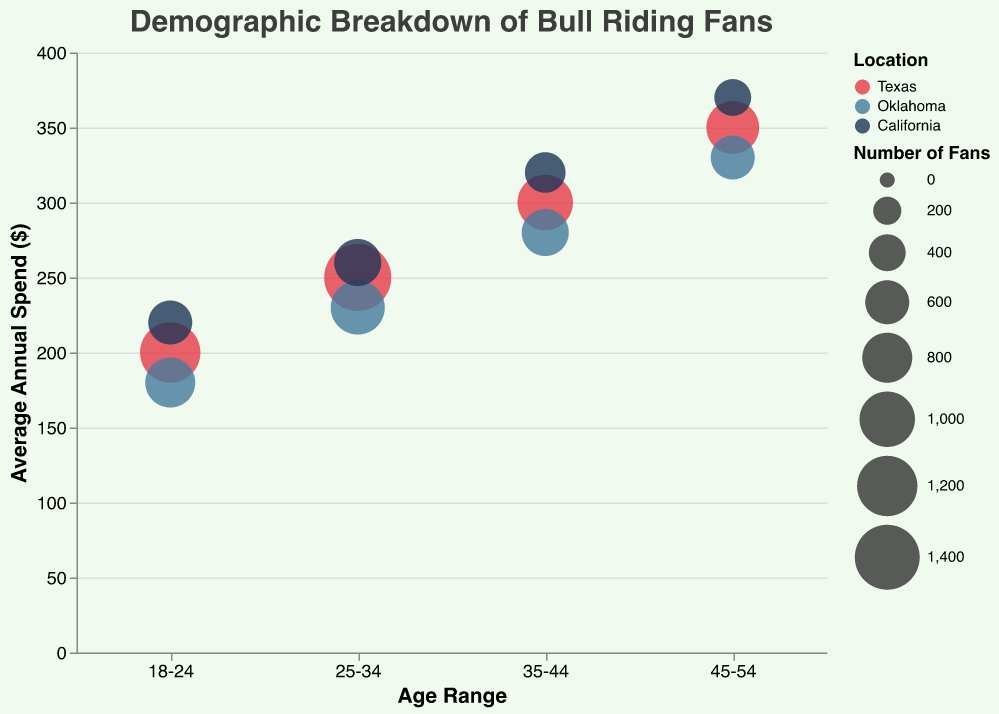What age range spends the least on average annually on bull riding? The bubble chart shows the annual spending on the y-axis, so we can look for the age range with the lowest position on the y-axis. The "18-24" age range has the lowest average annual spend, around $200.
Answer: 18-24 Which location has the highest number of fans in the 25-34 age range? By looking for the largest bubble size within the "25-34" age range, we can determine the number of fans. The largest bubble is for Texas.
Answer: Texas What is the average annual spend for 35-44-year-olds in California? Locate the "35-44" age range on the x-axis and find the bubble that corresponds to California. The y-axis value indicates the average annual spend. The value is approximately $320.
Answer: $320 How does the number of fans aged 45-54 in Oklahoma compare to those in Texas? Look at the bubble sizes for the "45-54" age range for both Oklahoma and Texas. The size for Texas is larger than for Oklahoma, indicating more fans in Texas.
Answer: Texas has more fans Which age range and location combination has the highest average annual spend? Find the highest point on the y-axis. The bubble at the highest position is in the "45-54" age range for California.
Answer: 45-54 in California For age range 25-34, which location has the smallest number of fans? In the "25-34" age range, compare the bubble sizes; the smallest bubble is for California.
Answer: California Does the average annual spend increase or decrease with age in Texas? Observing the y-axis positions of the bubbles for Texas, we see a trend of increasing average annual spend with age: $200 for 18-24, $250 for 25-34, $300 for 35-44, and $350 for 45-54.
Answer: Increase What is the difference in the number of fans between the 18-24 and 35-44 age ranges in Oklahoma? Identify the bubble sizes for Oklahoma in the 18-24 and 35-44 age ranges, then calculate the difference: 800 (18-24) - 700 (35-44) = 100.
Answer: 100 How many total data points are there in the figure? Each combination of age range and location results in one data point. With 4 age ranges and 3 locations, the total is 4 * 3 = 12.
Answer: 12 What is the relationship between the number of fans and the average annual spend across all age ranges in Texas? Comparing bubble sizes (number of fans) and their vertical positions (average annual spend) for Texas, generally, more fans (larger bubbles) are associated with lower average spend (lower y-axis values).
Answer: Inversely related 